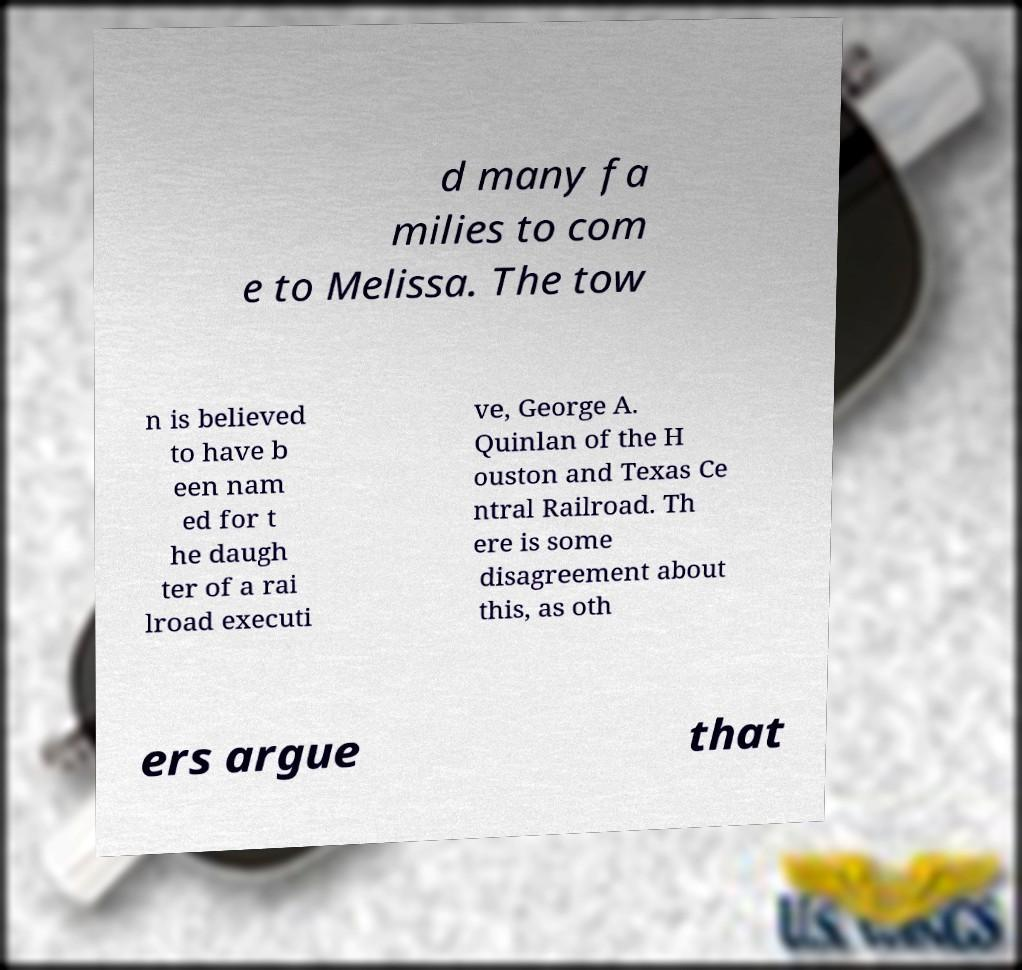For documentation purposes, I need the text within this image transcribed. Could you provide that? d many fa milies to com e to Melissa. The tow n is believed to have b een nam ed for t he daugh ter of a rai lroad executi ve, George A. Quinlan of the H ouston and Texas Ce ntral Railroad. Th ere is some disagreement about this, as oth ers argue that 